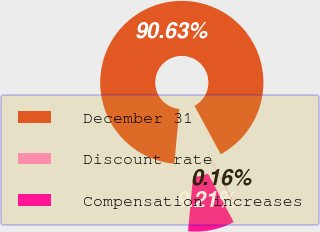<chart> <loc_0><loc_0><loc_500><loc_500><pie_chart><fcel>December 31<fcel>Discount rate<fcel>Compensation increases<nl><fcel>90.63%<fcel>0.16%<fcel>9.21%<nl></chart> 